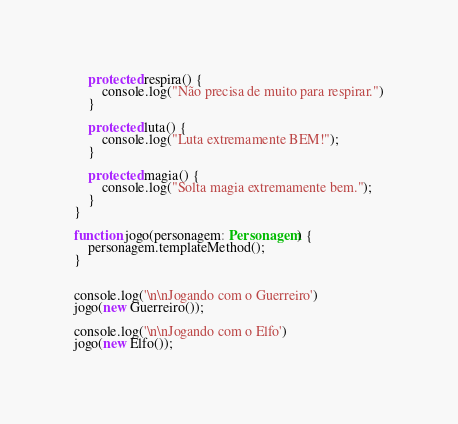<code> <loc_0><loc_0><loc_500><loc_500><_TypeScript_>
    protected respira() {
        console.log("Não precisa de muito para respirar.")
    }

    protected luta() {
        console.log("Luta extremamente BEM!");
    }

    protected magia() {
        console.log("Solta magia extremamente bem.");
    }
}

function jogo(personagem: Personagem) {
    personagem.templateMethod();
}


console.log('\n\nJogando com o Guerreiro')
jogo(new Guerreiro());

console.log('\n\nJogando com o Elfo')
jogo(new Elfo());

</code> 